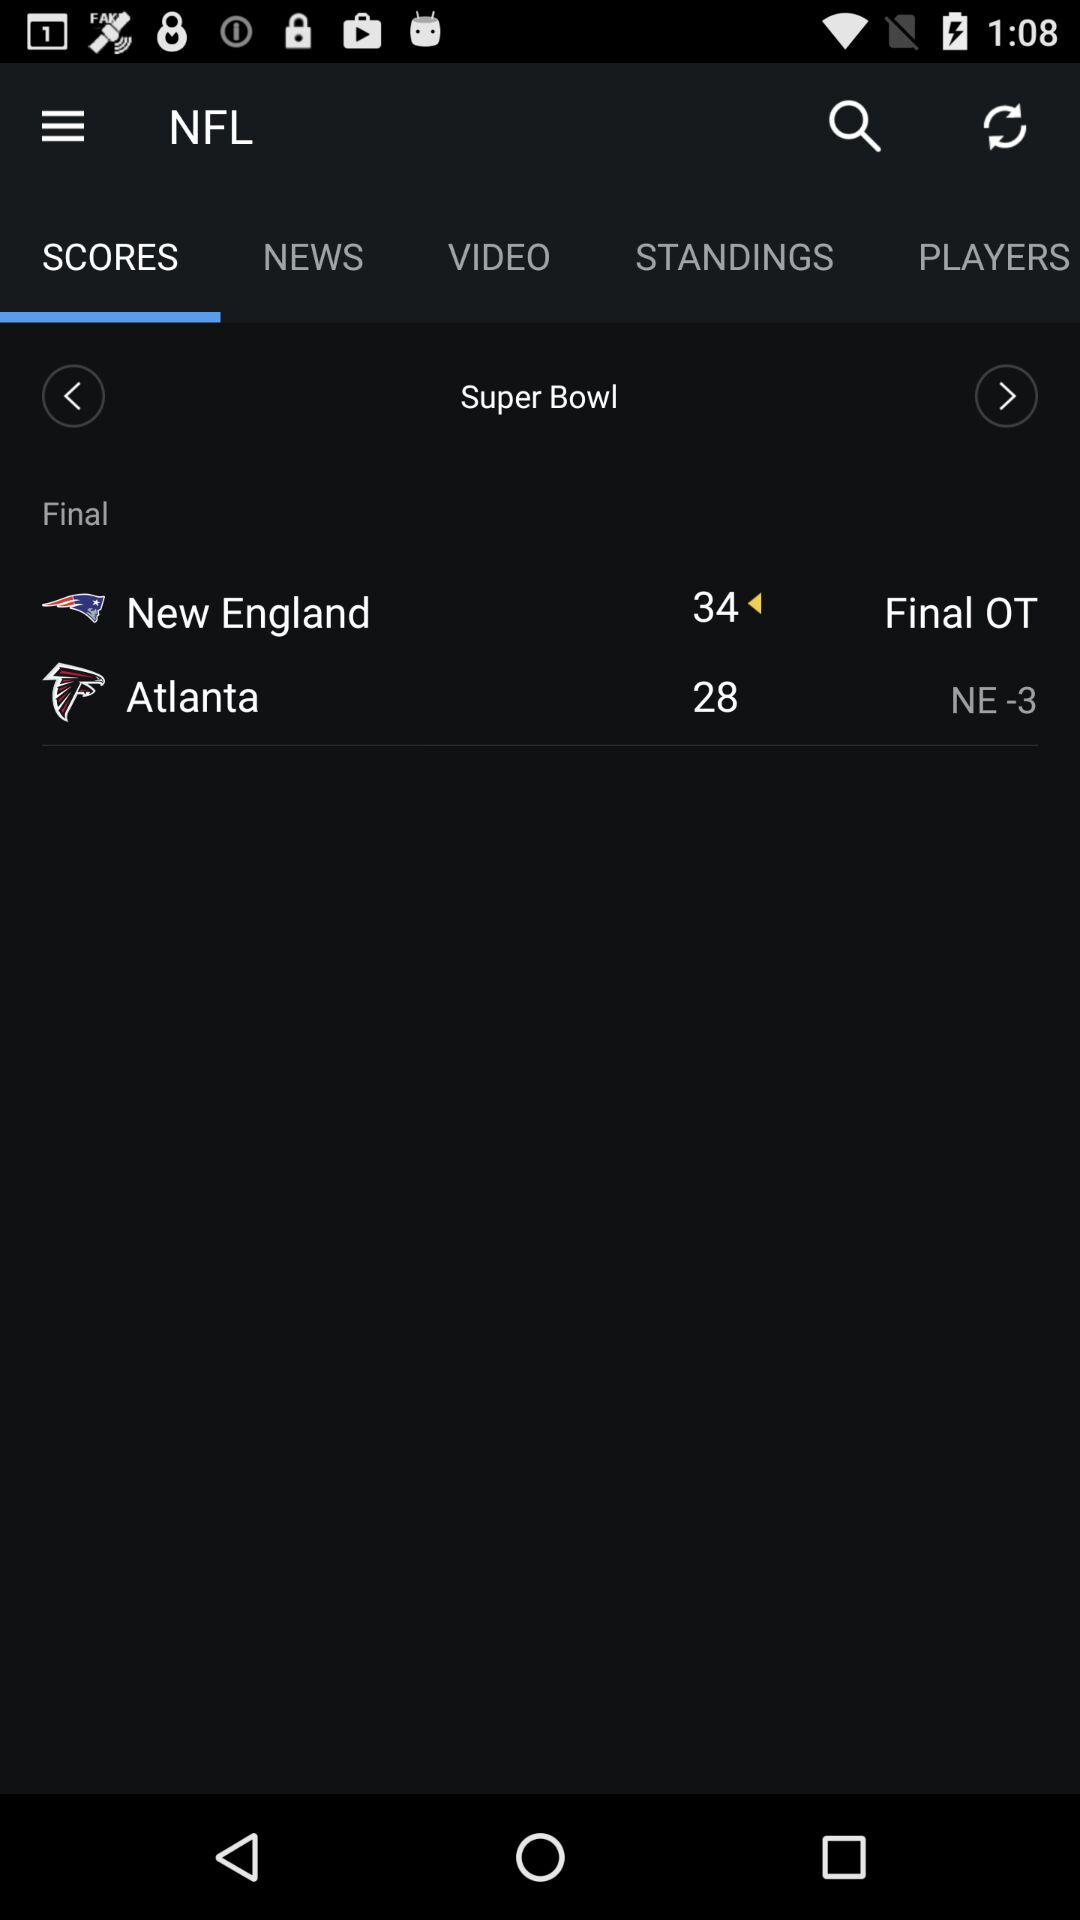What is the score for New England? The score is 34. 